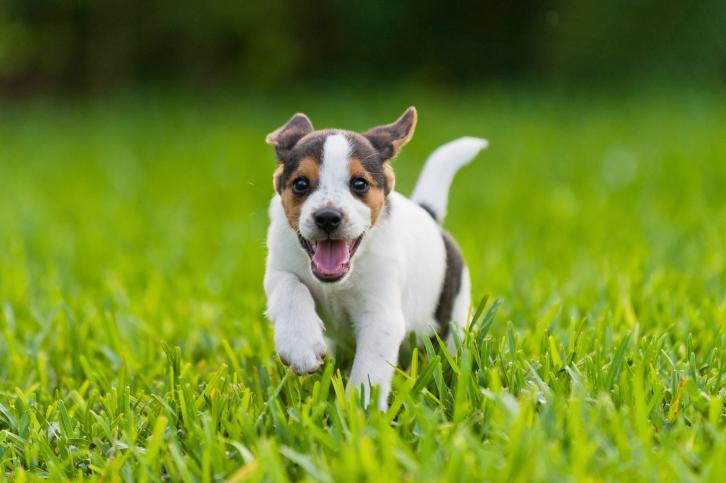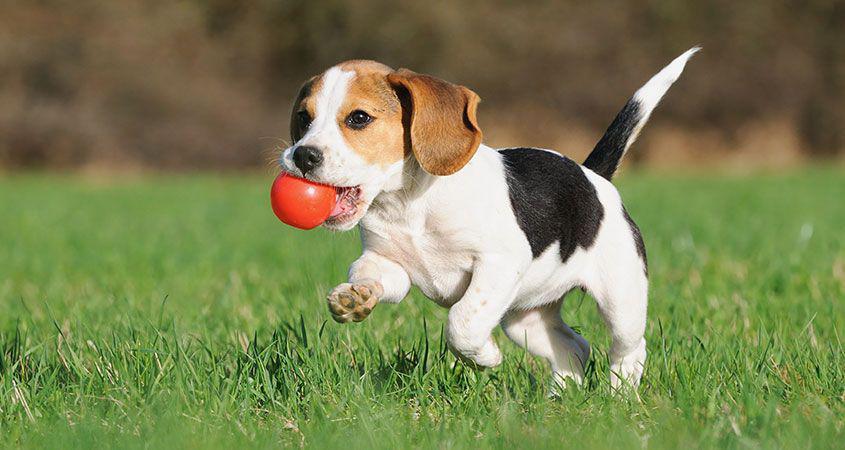The first image is the image on the left, the second image is the image on the right. Given the left and right images, does the statement "Both images in the pair contain only one dog." hold true? Answer yes or no. Yes. The first image is the image on the left, the second image is the image on the right. Evaluate the accuracy of this statement regarding the images: "There are no more than two puppies.". Is it true? Answer yes or no. Yes. 